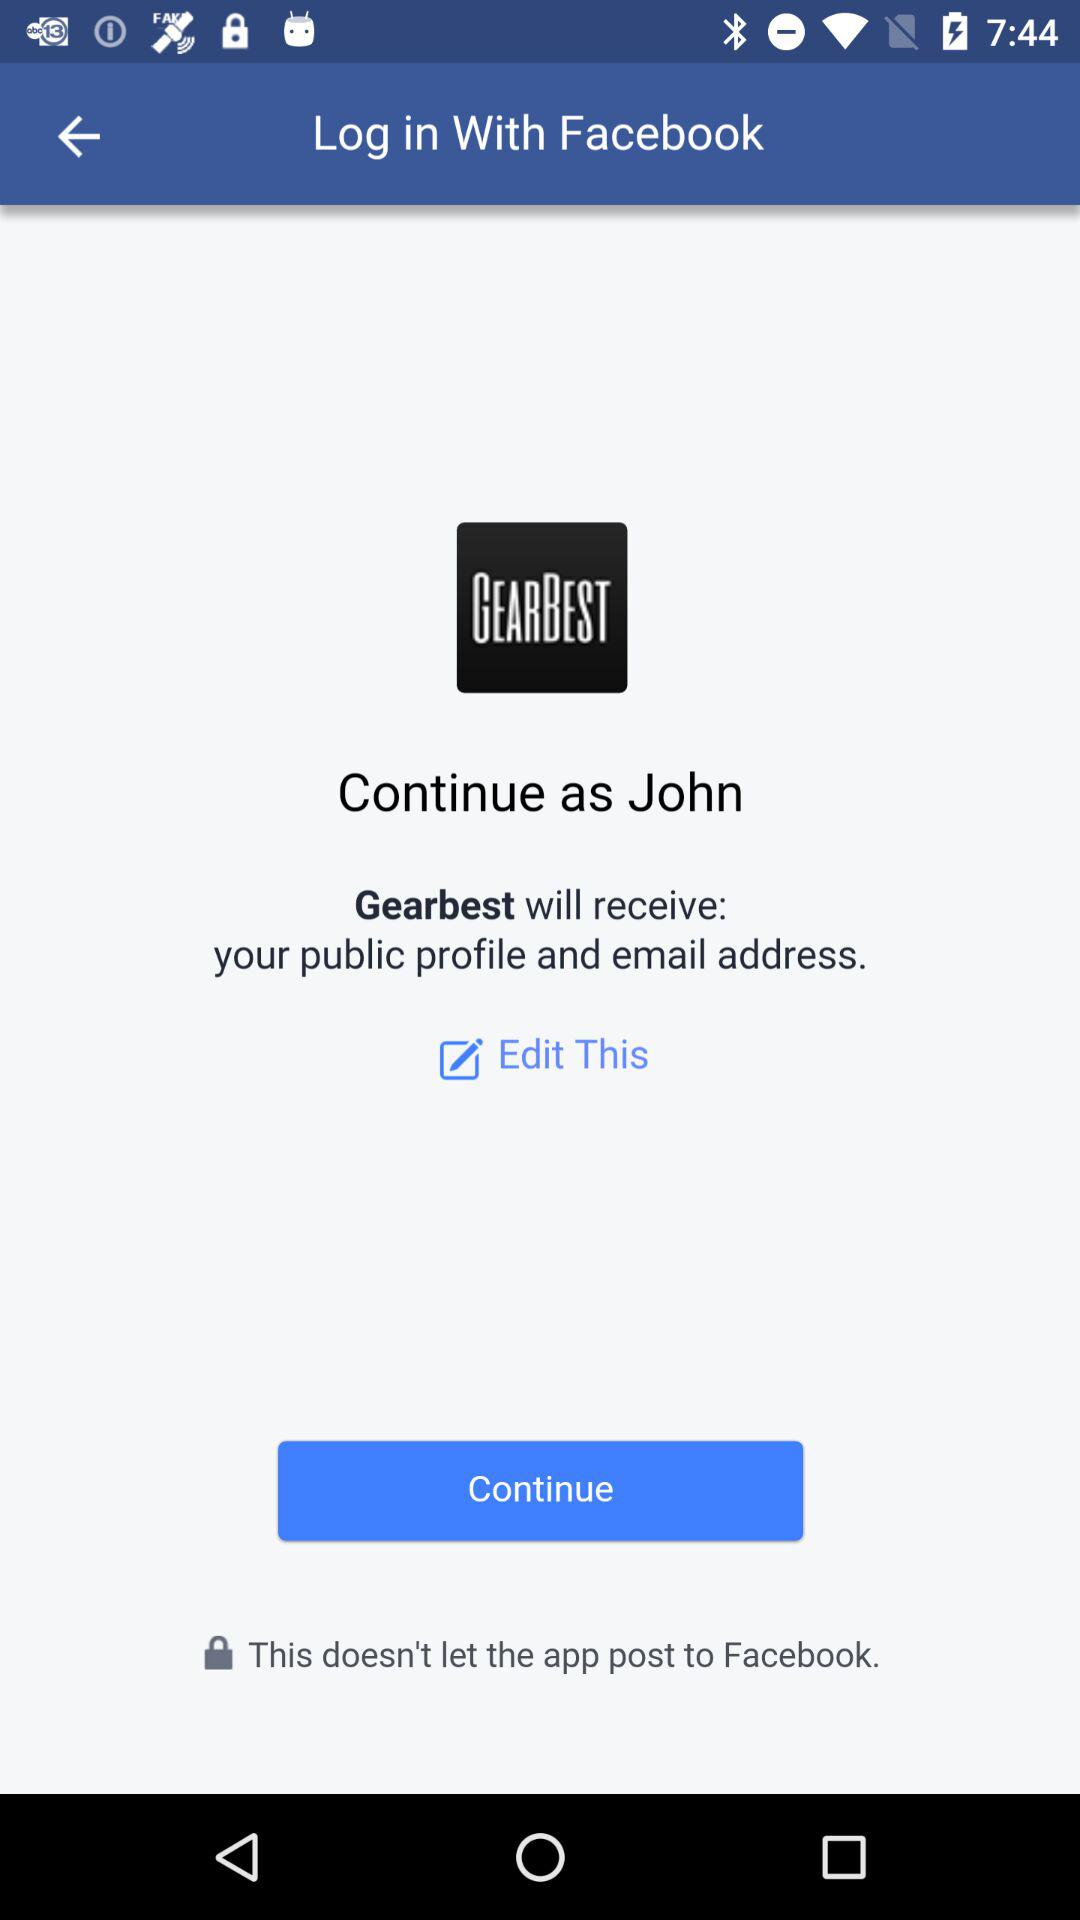What is the login name? The login name is "John". 